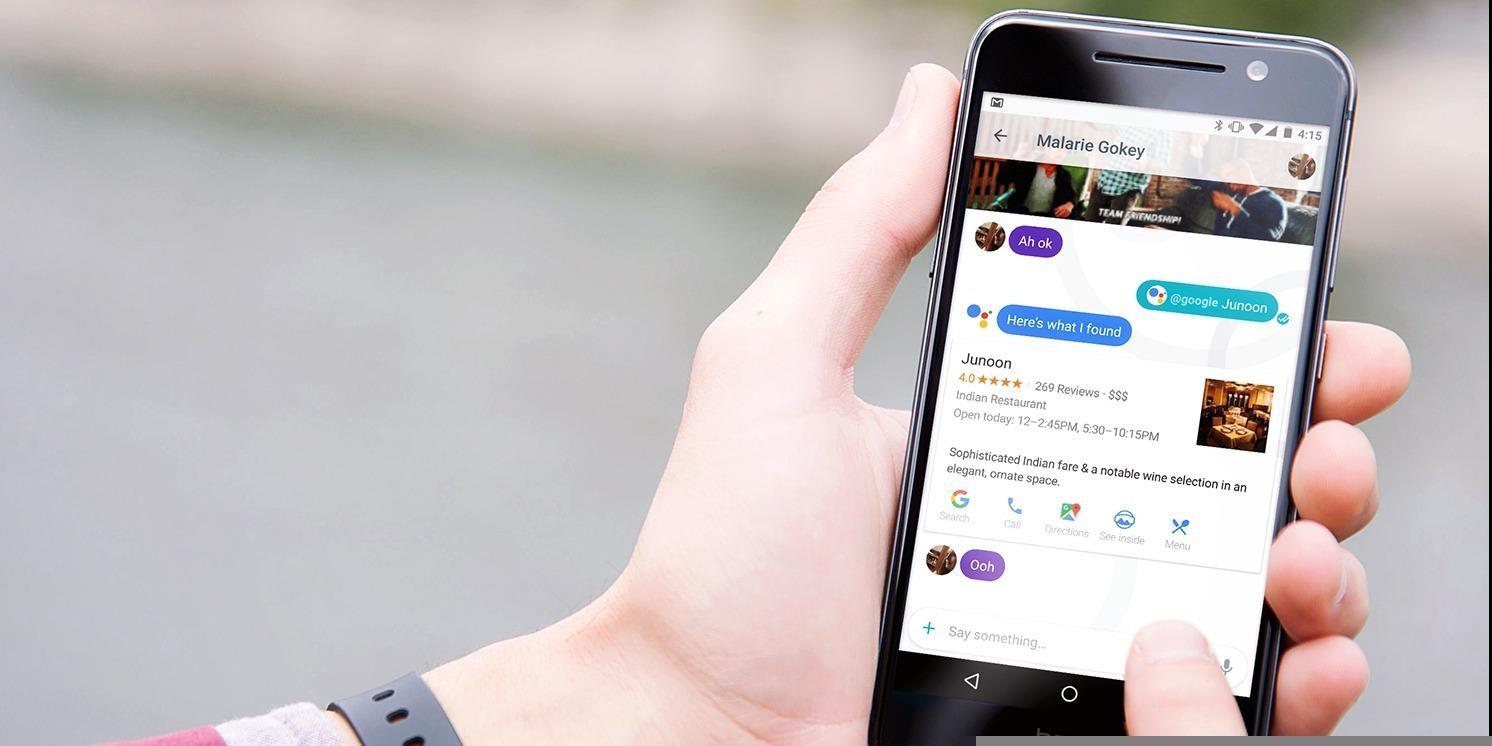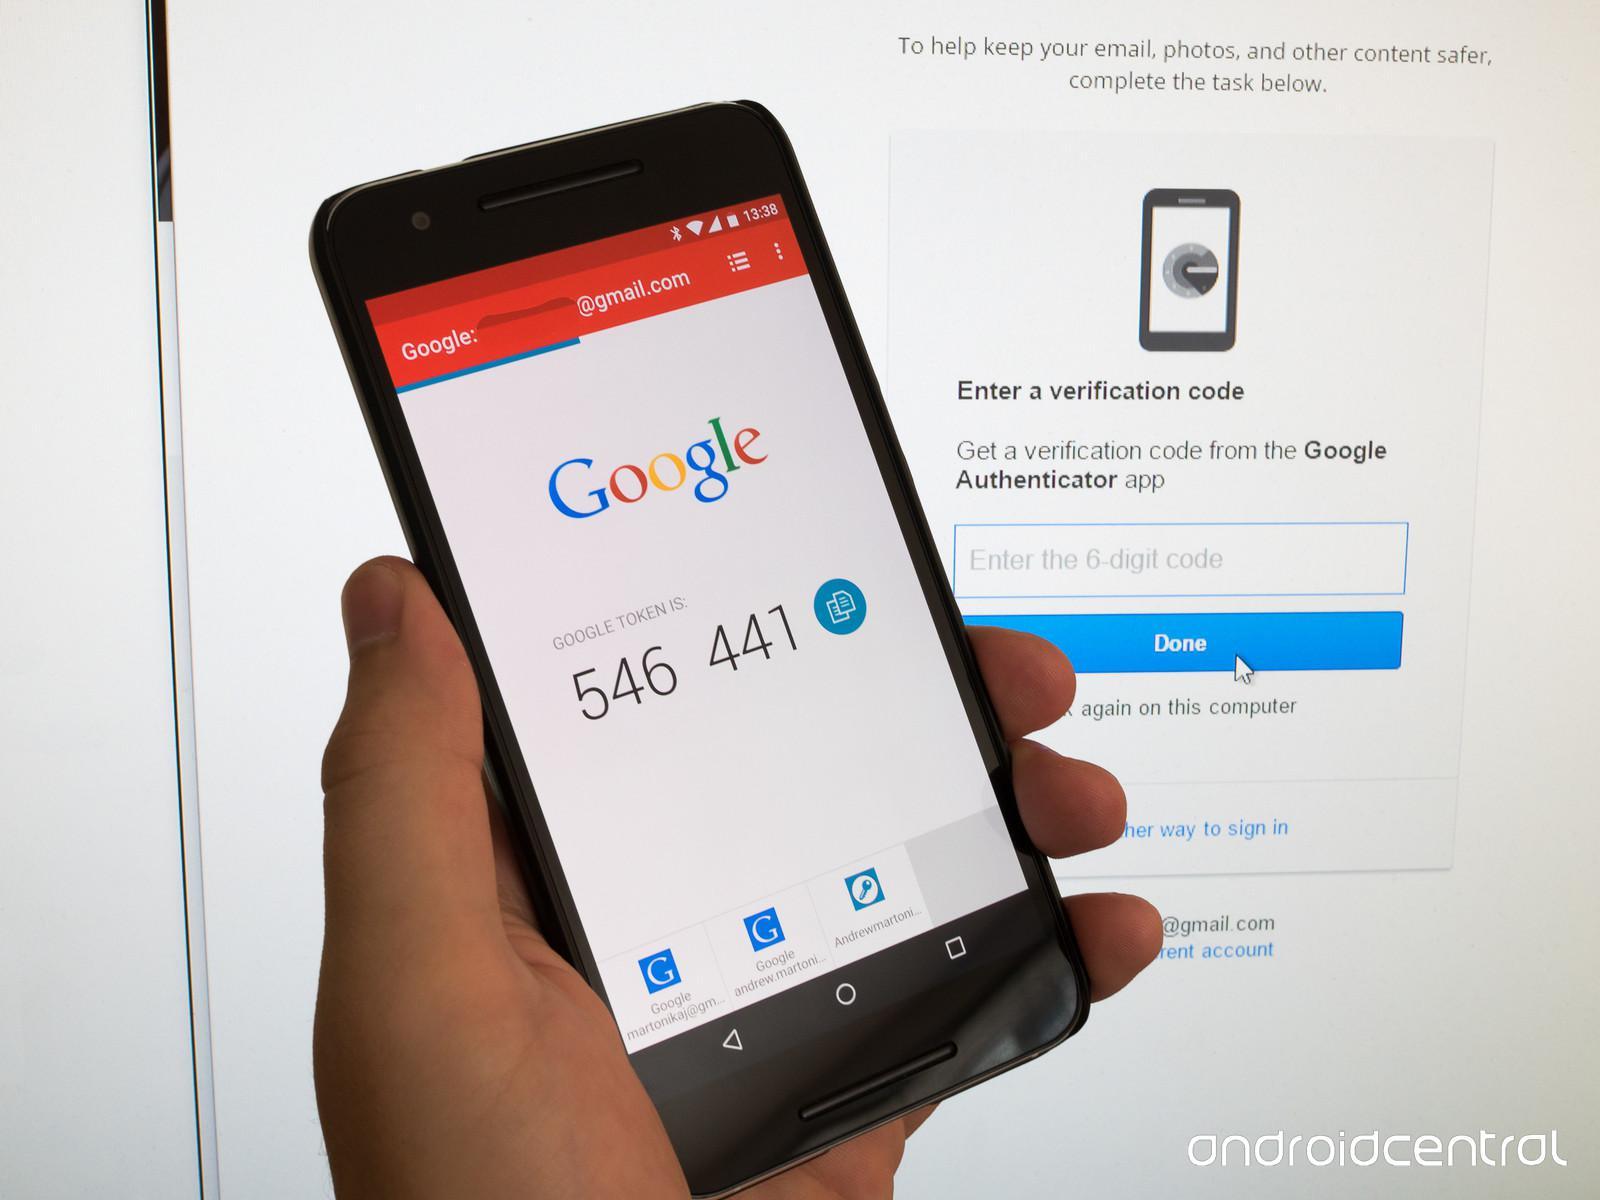The first image is the image on the left, the second image is the image on the right. For the images displayed, is the sentence "The left image features two palms-up hands, each holding a screen-side up phone next to the other phone." factually correct? Answer yes or no. No. The first image is the image on the left, the second image is the image on the right. Assess this claim about the two images: "The left and right image contains a total of four phones.". Correct or not? Answer yes or no. No. 